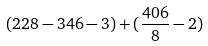<formula> <loc_0><loc_0><loc_500><loc_500>( 2 2 8 - 3 4 6 - 3 ) + ( \frac { 4 0 6 } { 8 } - 2 )</formula> 